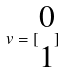Convert formula to latex. <formula><loc_0><loc_0><loc_500><loc_500>v = [ \begin{matrix} 0 \\ 1 \end{matrix} ]</formula> 